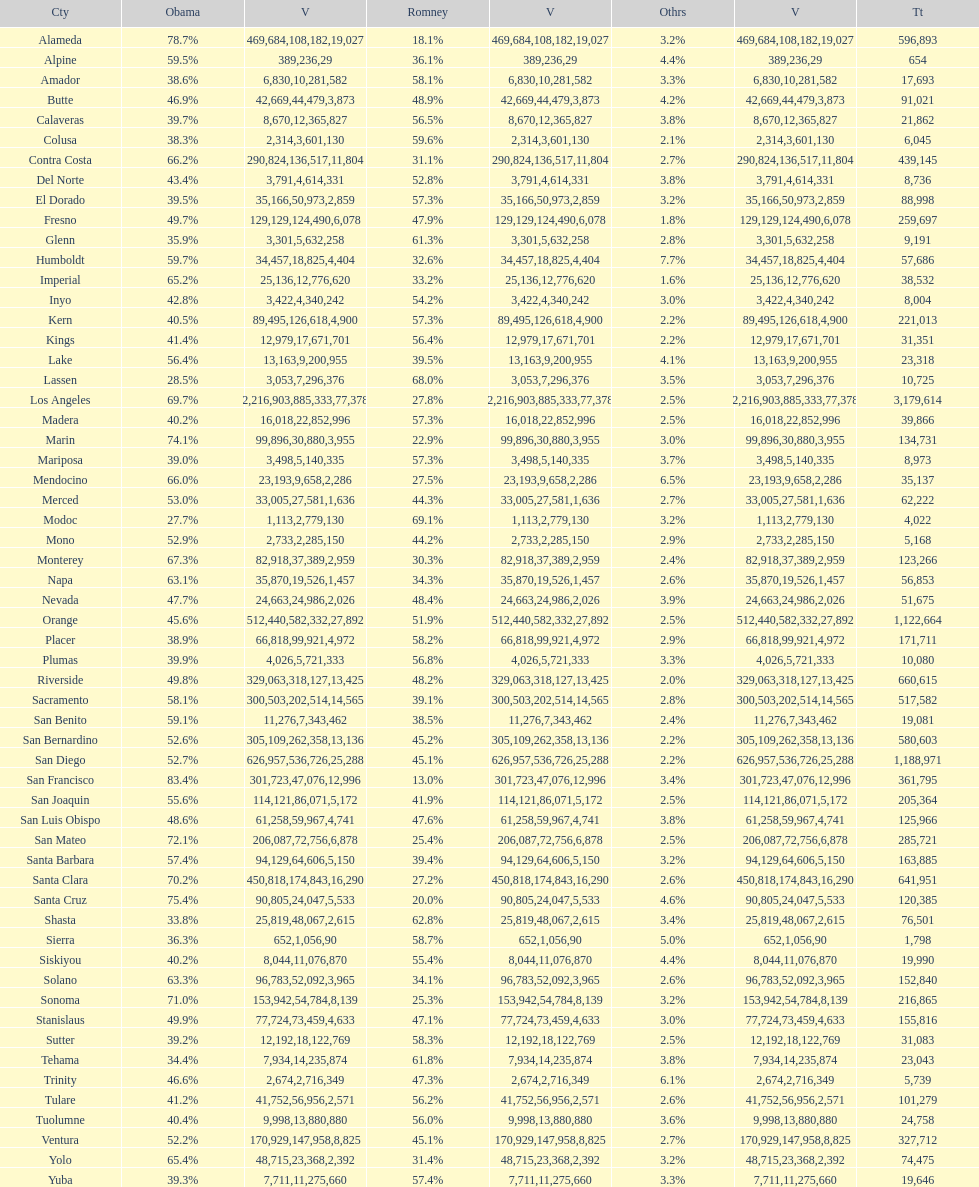What is the total number of votes for amador? 17693. 